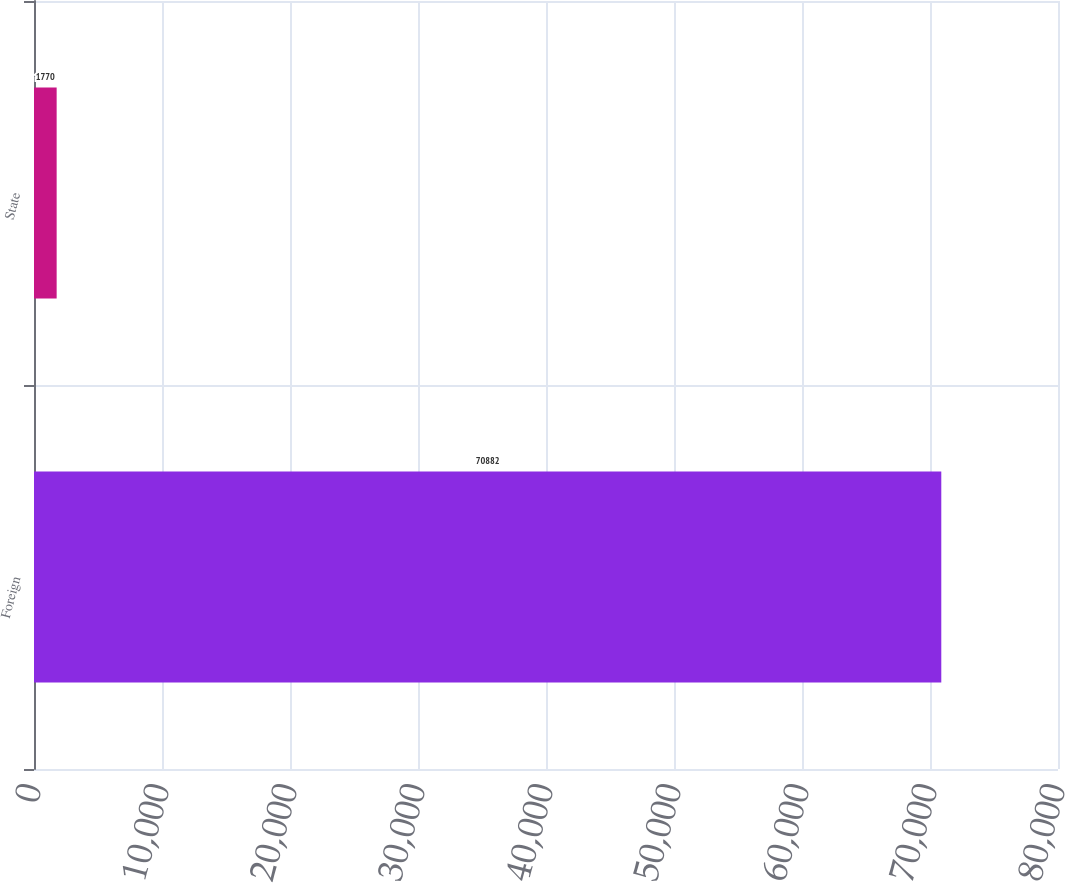Convert chart to OTSL. <chart><loc_0><loc_0><loc_500><loc_500><bar_chart><fcel>Foreign<fcel>State<nl><fcel>70882<fcel>1770<nl></chart> 